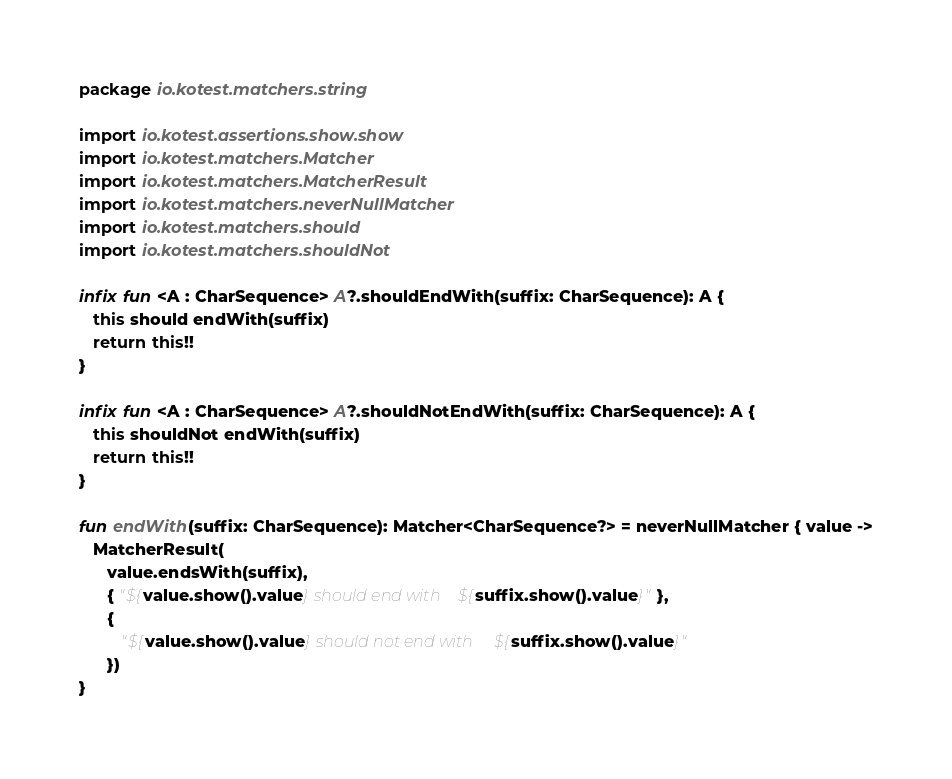<code> <loc_0><loc_0><loc_500><loc_500><_Kotlin_>package io.kotest.matchers.string

import io.kotest.assertions.show.show
import io.kotest.matchers.Matcher
import io.kotest.matchers.MatcherResult
import io.kotest.matchers.neverNullMatcher
import io.kotest.matchers.should
import io.kotest.matchers.shouldNot

infix fun <A : CharSequence> A?.shouldEndWith(suffix: CharSequence): A {
   this should endWith(suffix)
   return this!!
}

infix fun <A : CharSequence> A?.shouldNotEndWith(suffix: CharSequence): A {
   this shouldNot endWith(suffix)
   return this!!
}

fun endWith(suffix: CharSequence): Matcher<CharSequence?> = neverNullMatcher { value ->
   MatcherResult(
      value.endsWith(suffix),
      { "${value.show().value} should end with ${suffix.show().value}" },
      {
         "${value.show().value} should not end with ${suffix.show().value}"
      })
}
</code> 